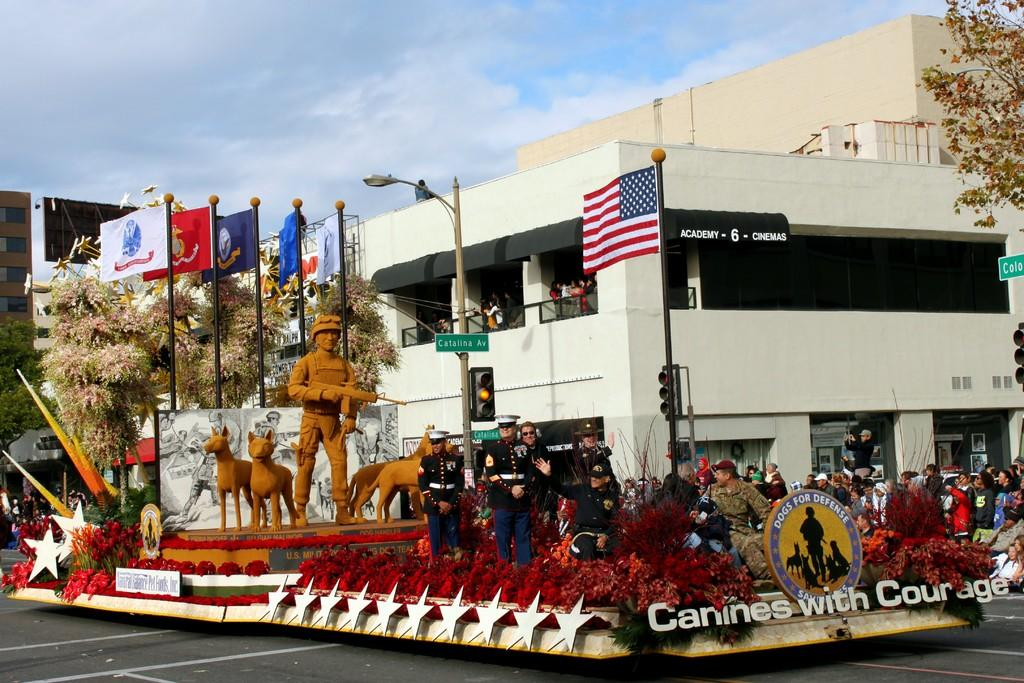<image>
Share a concise interpretation of the image provided. A float in a parade for Canines with Courage. 